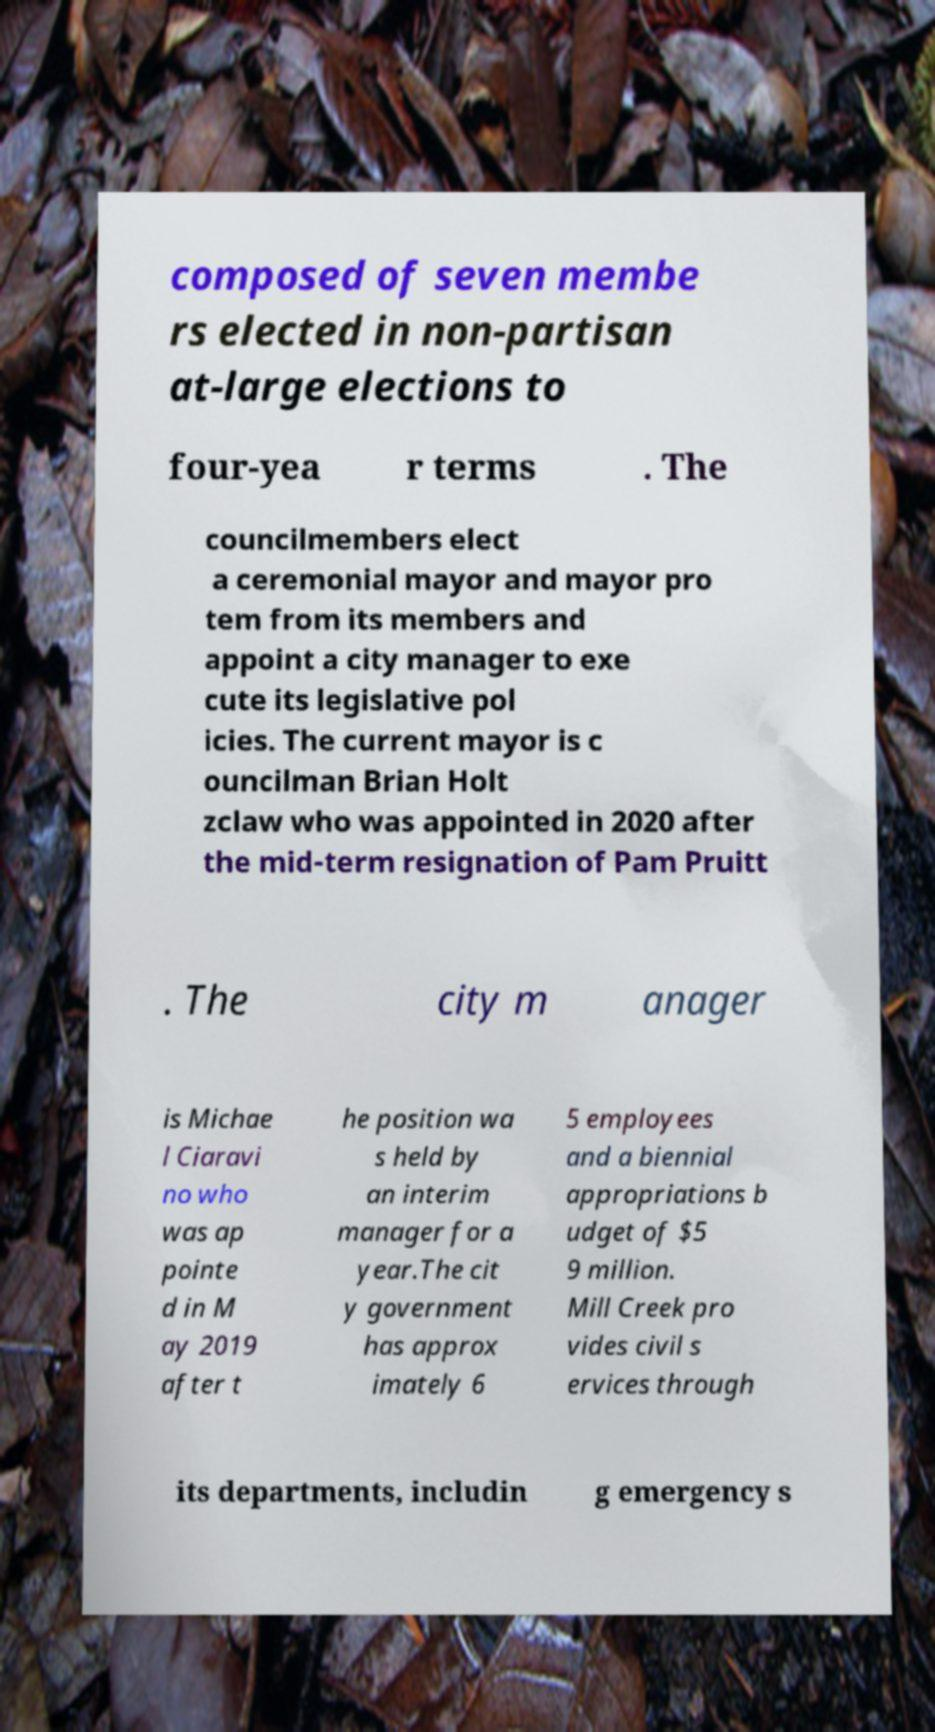Can you read and provide the text displayed in the image?This photo seems to have some interesting text. Can you extract and type it out for me? composed of seven membe rs elected in non-partisan at-large elections to four-yea r terms . The councilmembers elect a ceremonial mayor and mayor pro tem from its members and appoint a city manager to exe cute its legislative pol icies. The current mayor is c ouncilman Brian Holt zclaw who was appointed in 2020 after the mid-term resignation of Pam Pruitt . The city m anager is Michae l Ciaravi no who was ap pointe d in M ay 2019 after t he position wa s held by an interim manager for a year.The cit y government has approx imately 6 5 employees and a biennial appropriations b udget of $5 9 million. Mill Creek pro vides civil s ervices through its departments, includin g emergency s 